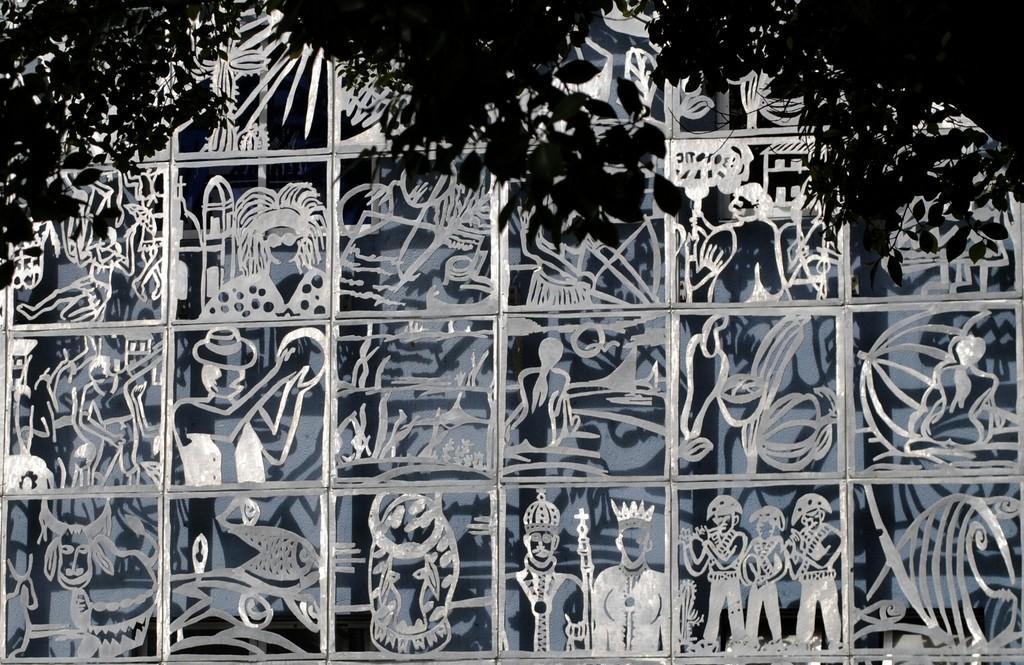Can you describe this image briefly? This picture is a black and white image. In this image we can see some art on the glass and some trees at the top of the image. 